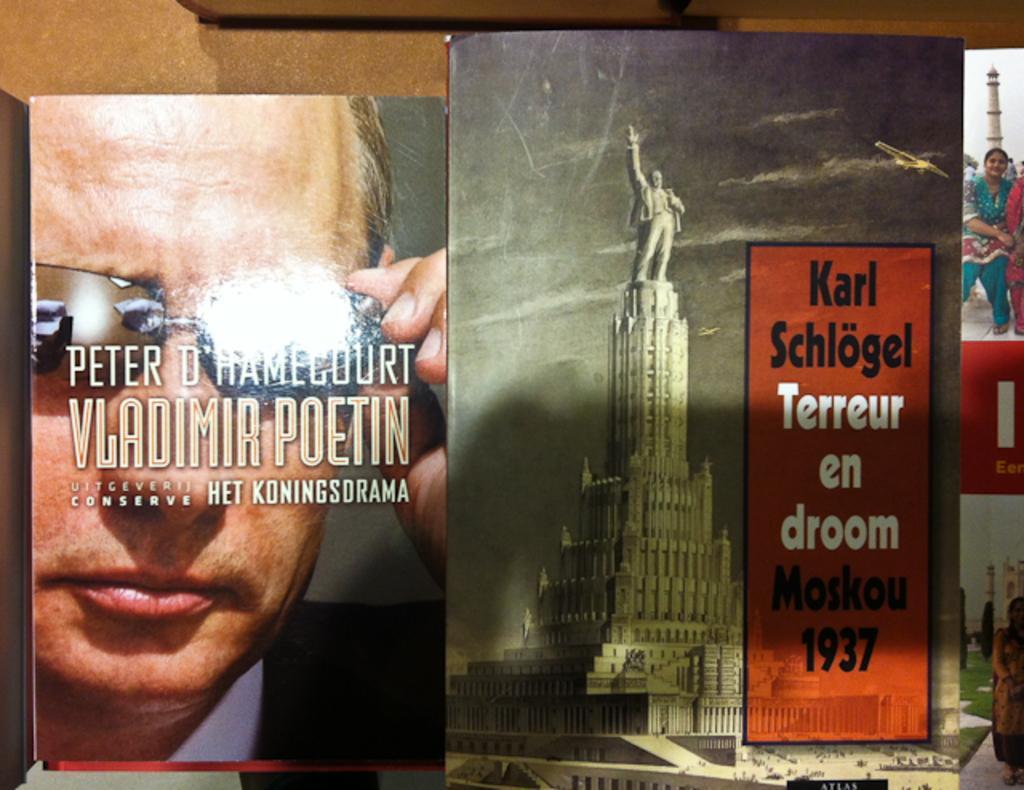Could you give a brief overview of what you see in this image? In the image there are wallpapers with pictures of statues,women,men and text on it in front of wall. 